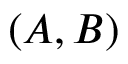<formula> <loc_0><loc_0><loc_500><loc_500>( A , B )</formula> 